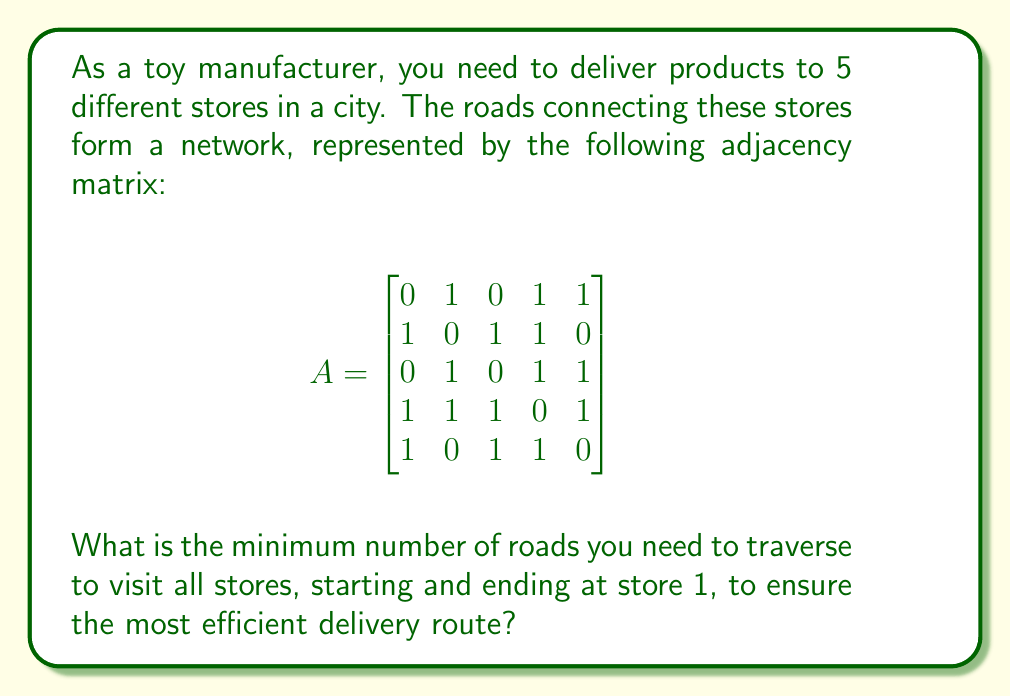Can you solve this math problem? To solve this problem, we'll use graph theory concepts and the adjacency matrix provided:

1) First, we need to understand what the adjacency matrix represents:
   - Each row and column corresponds to a store (1 to 5).
   - A '1' in position $(i,j)$ means there's a direct road from store $i$ to store $j$.
   - A '0' means no direct connection.

2) Our goal is to find a Hamiltonian cycle (a path that visits each vertex exactly once and returns to the start) with the minimum number of edges.

3) We can see that the graph is highly connected. In fact, it's almost a complete graph.

4) Let's count the connections for each store:
   - Store 1: 3 connections
   - Store 2: 3 connections
   - Store 3: 3 connections
   - Store 4: 4 connections
   - Store 5: 3 connections

5) Since store 4 has the most connections (4), it's a good candidate to be in the middle of our path.

6) A possible minimum path would be: 1 - 5 - 3 - 4 - 2 - 1

7) This path uses 5 edges, which is the minimum possible for a graph with 5 vertices.

8) We can verify this path using the adjacency matrix:
   - $A_{15} = 1$ (1 to 5 is connected)
   - $A_{53} = 1$ (5 to 3 is connected)
   - $A_{34} = 1$ (3 to 4 is connected)
   - $A_{42} = 1$ (4 to 2 is connected)
   - $A_{21} = 1$ (2 to 1 is connected)

Therefore, the minimum number of roads to traverse is 5.
Answer: 5 